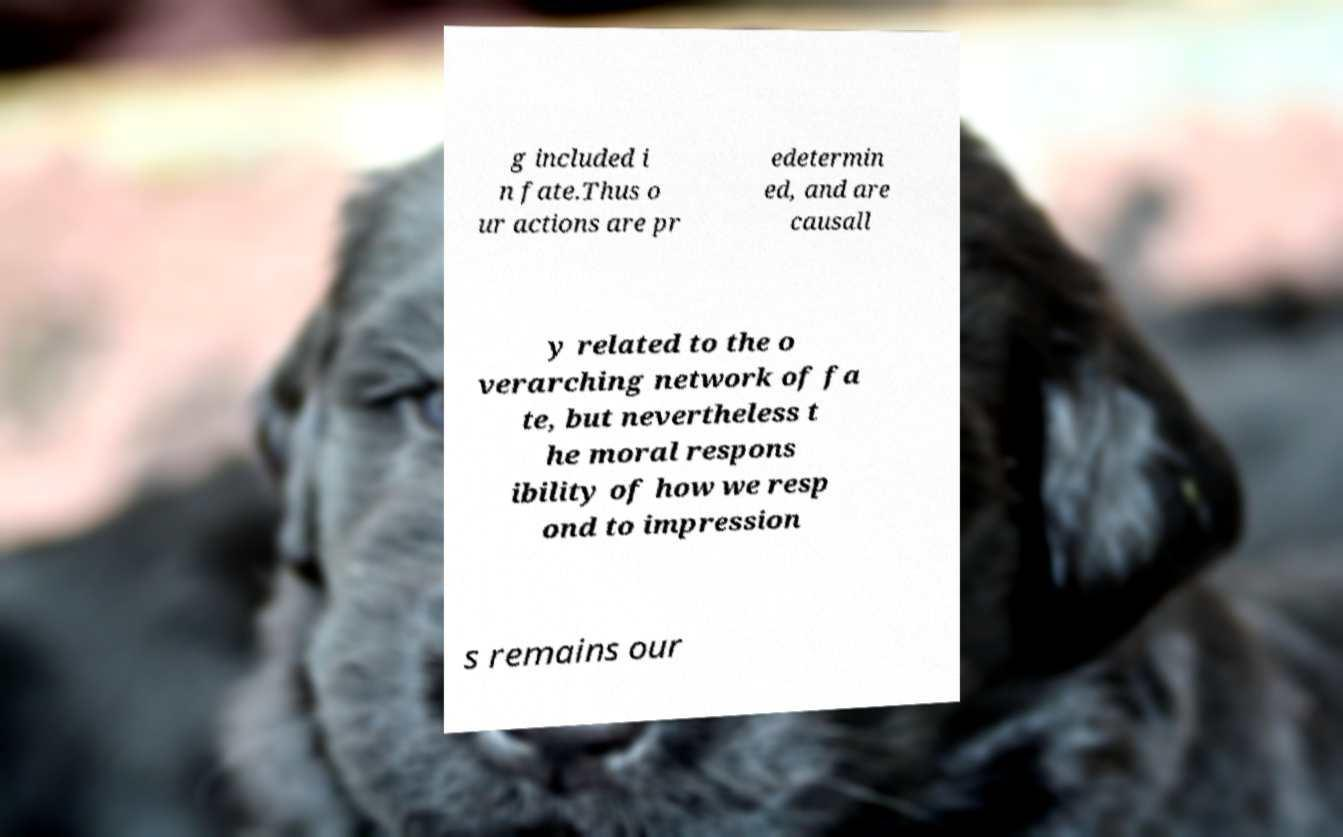For documentation purposes, I need the text within this image transcribed. Could you provide that? g included i n fate.Thus o ur actions are pr edetermin ed, and are causall y related to the o verarching network of fa te, but nevertheless t he moral respons ibility of how we resp ond to impression s remains our 